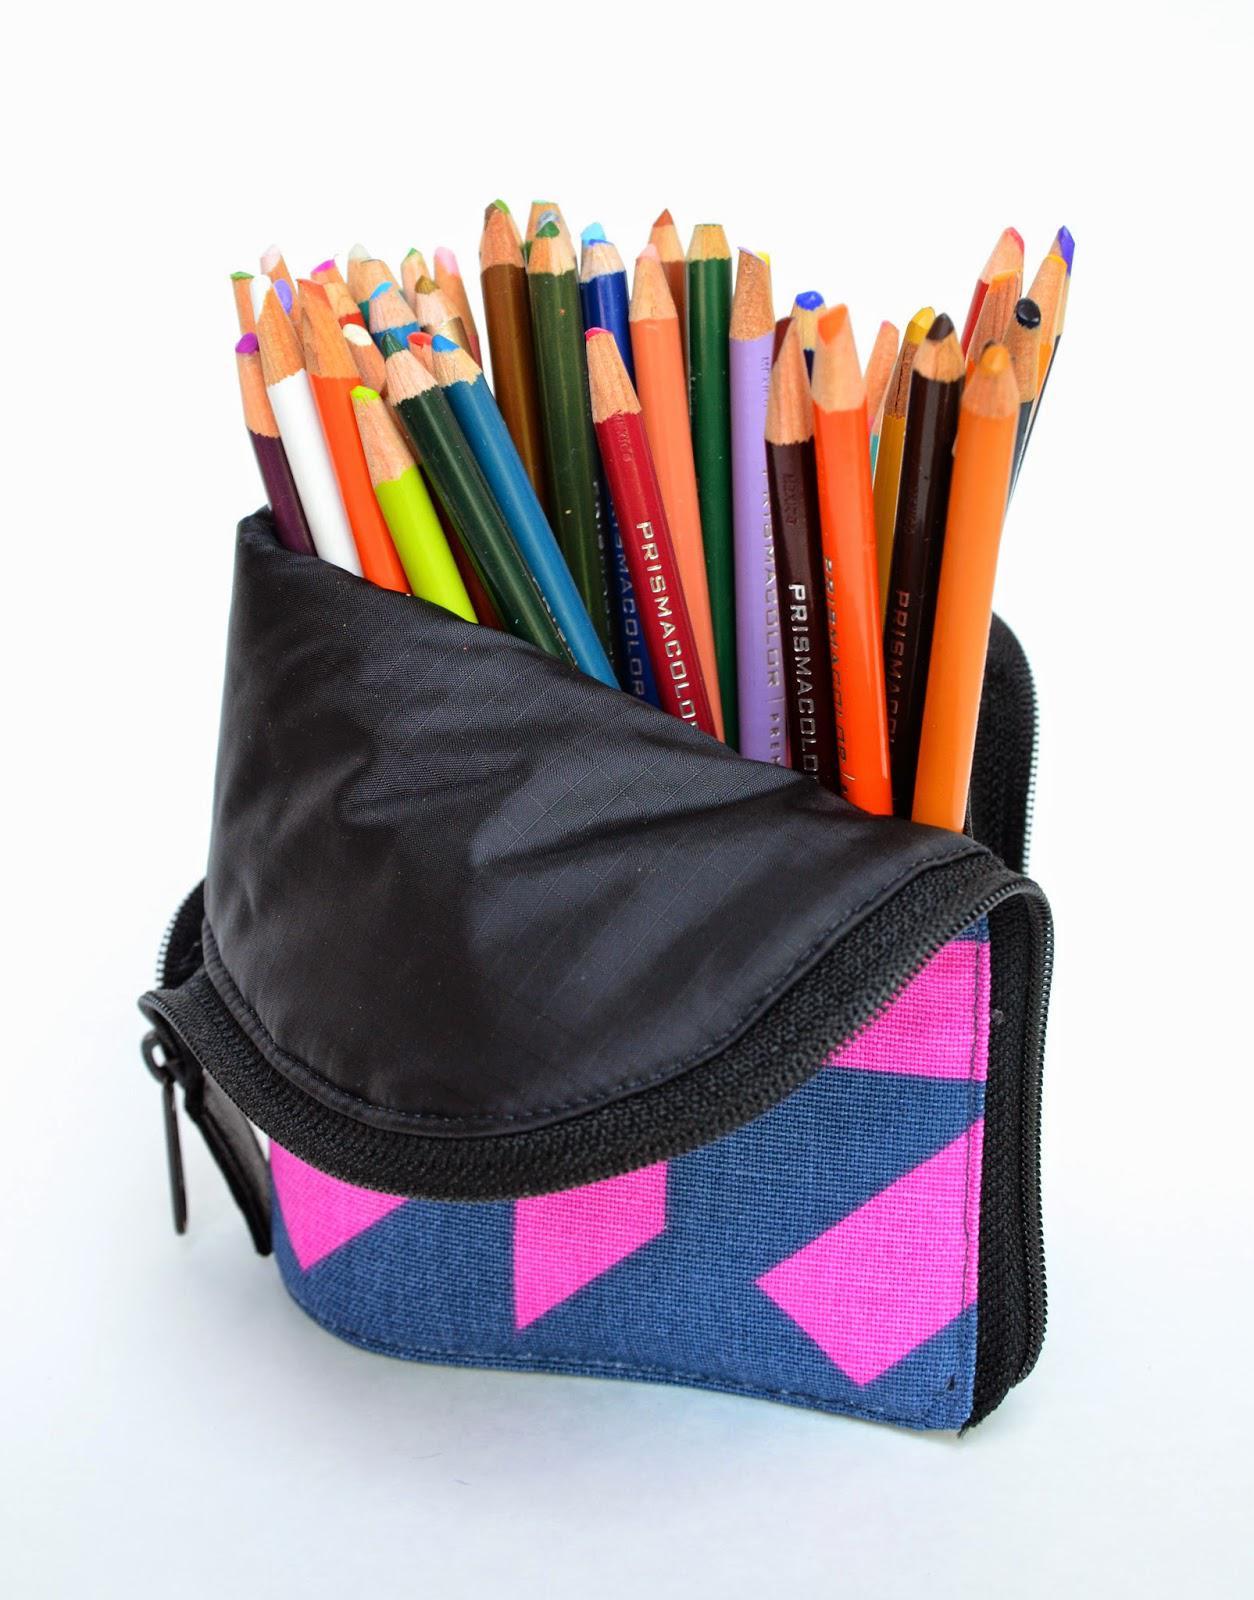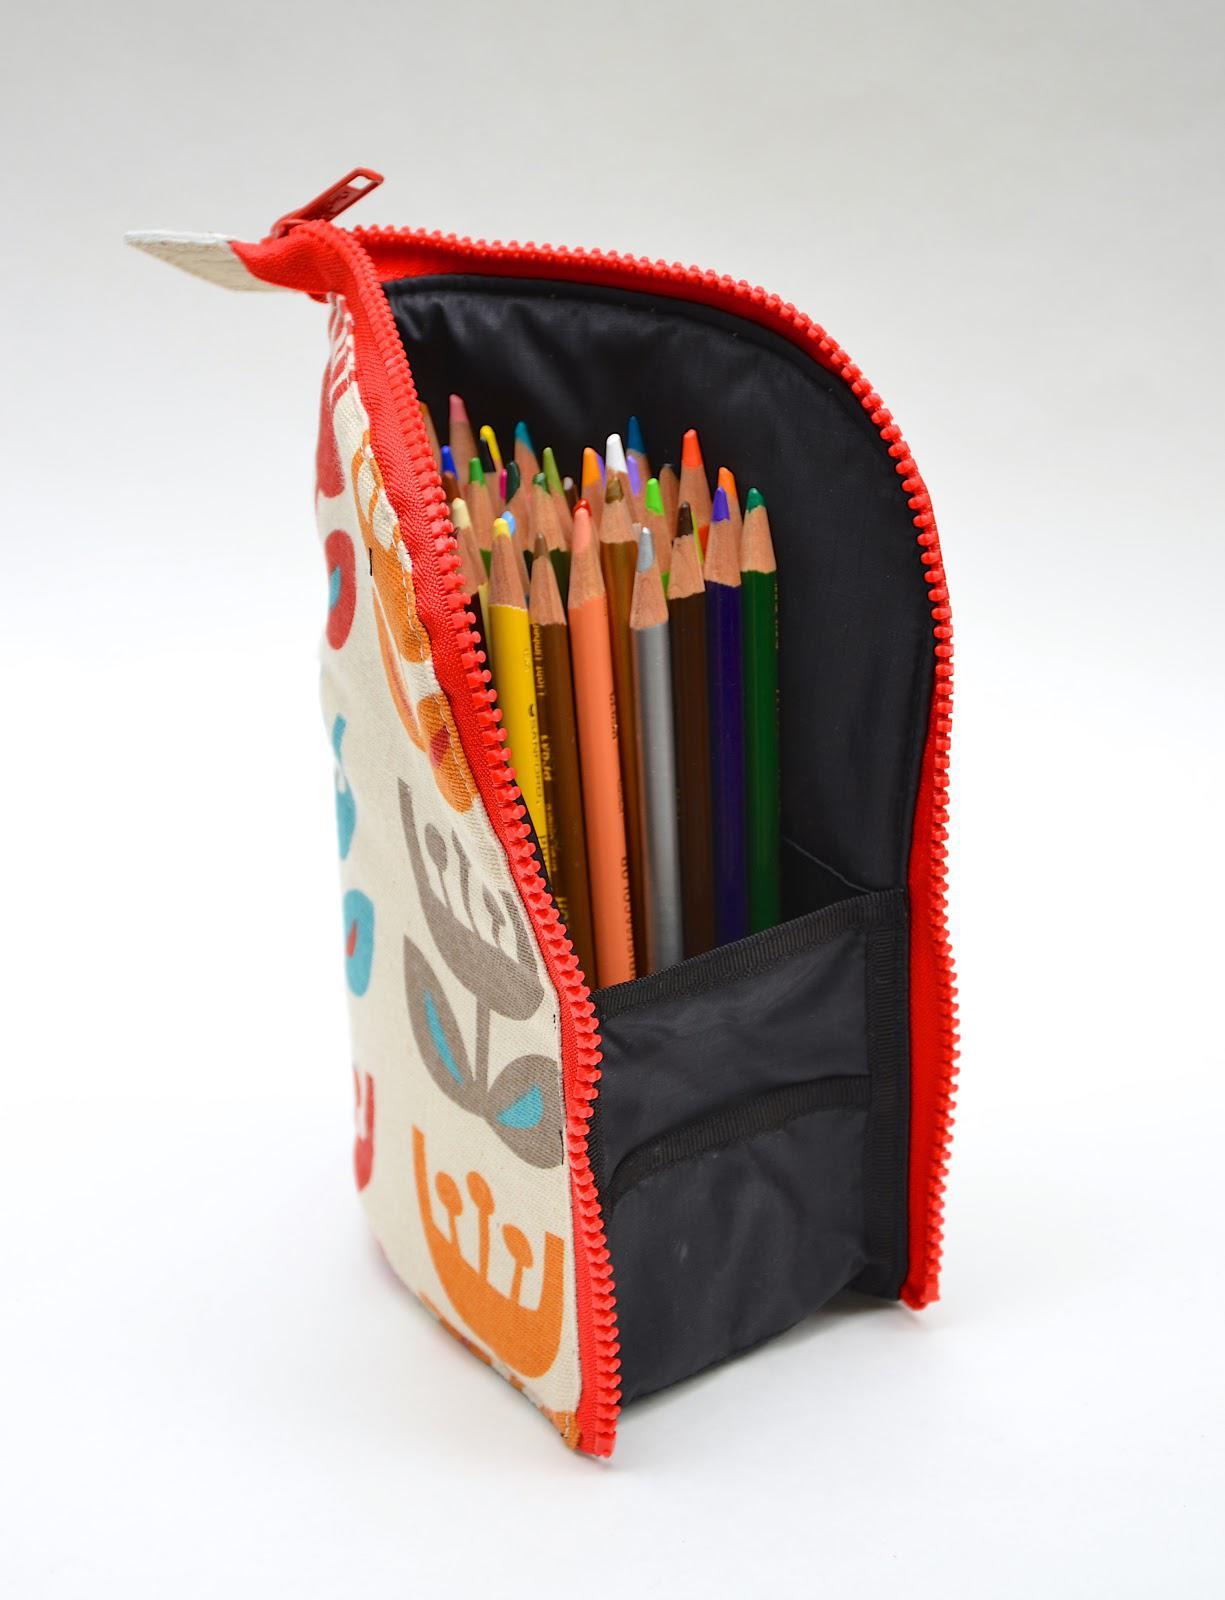The first image is the image on the left, the second image is the image on the right. Considering the images on both sides, is "The pens in the image on the left are near colored pencils." valid? Answer yes or no. No. The first image is the image on the left, the second image is the image on the right. Analyze the images presented: Is the assertion "The right image shows a zipper case with a graphic print on its exterior functioning as an upright holder for colored pencils." valid? Answer yes or no. Yes. 